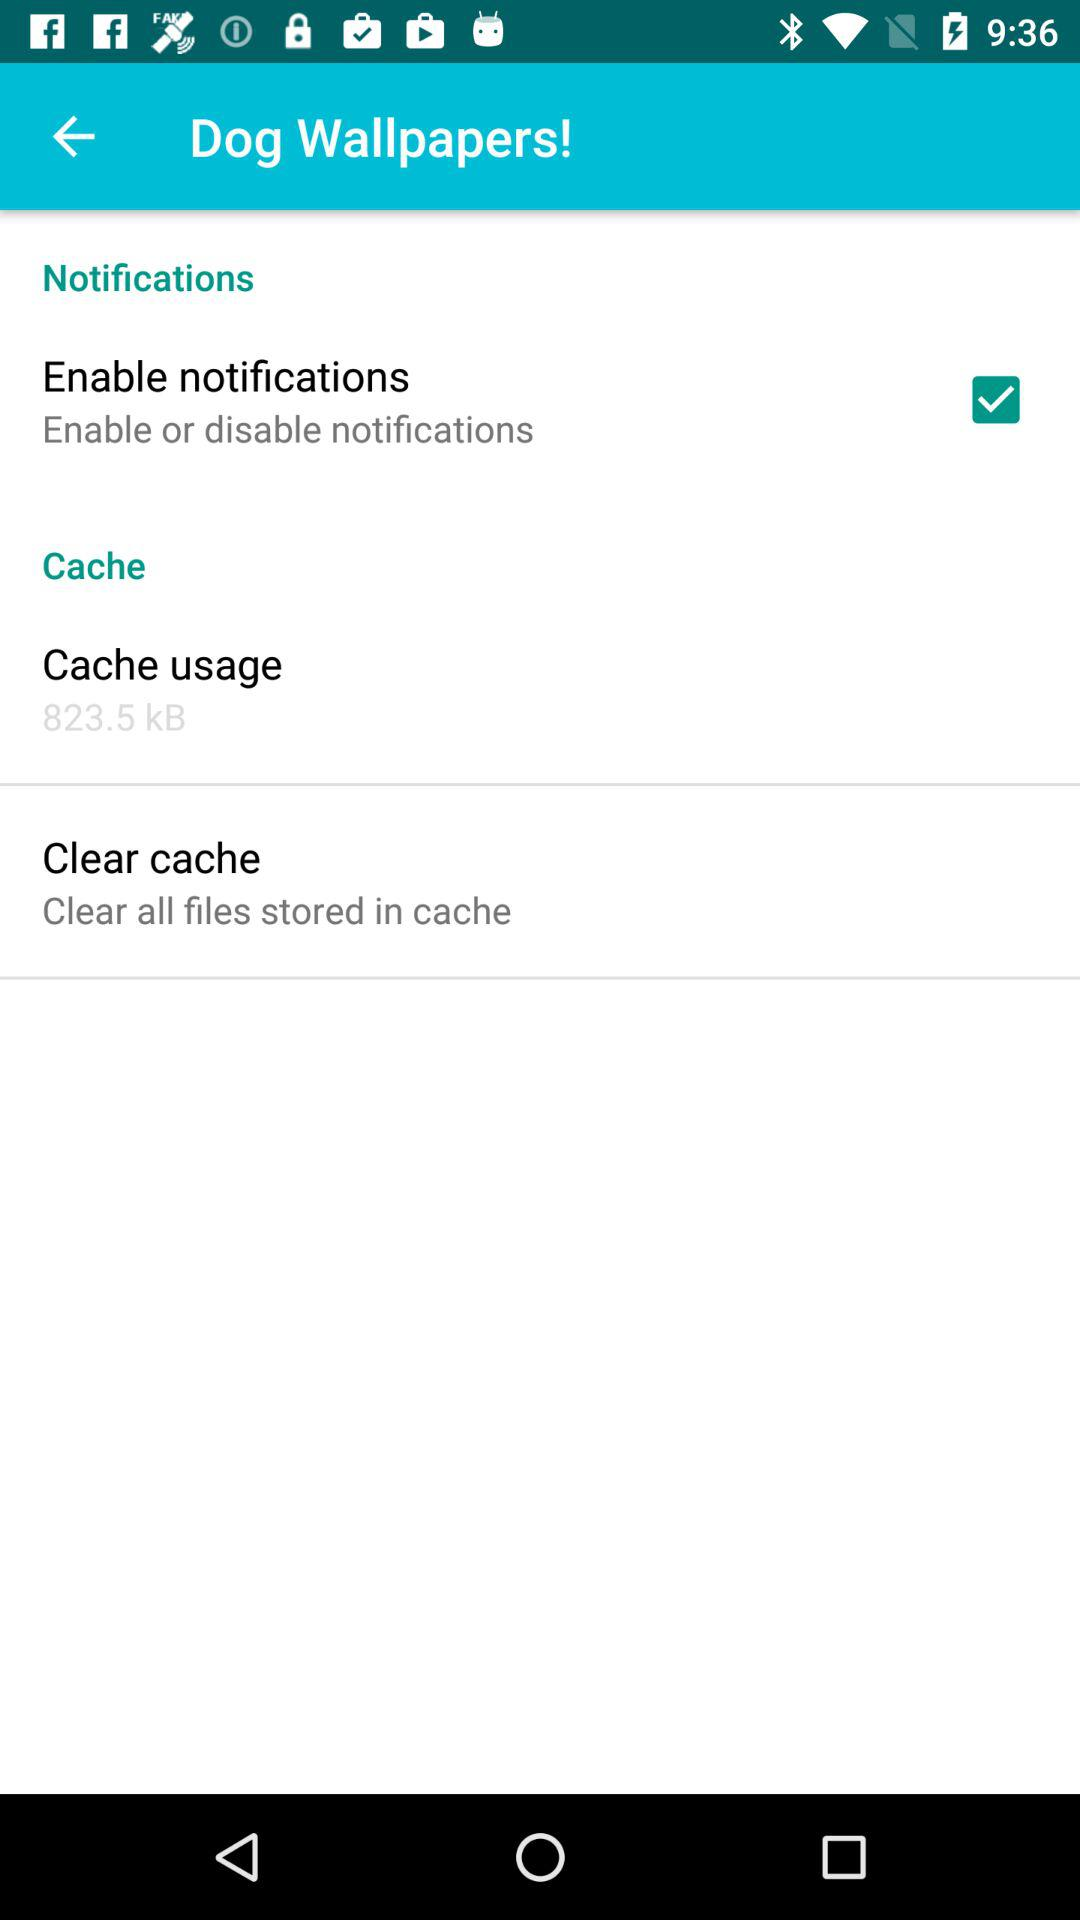How much cache is in "Cashe usage"? There is 823.5 kB of cache in "Cashe usage". 